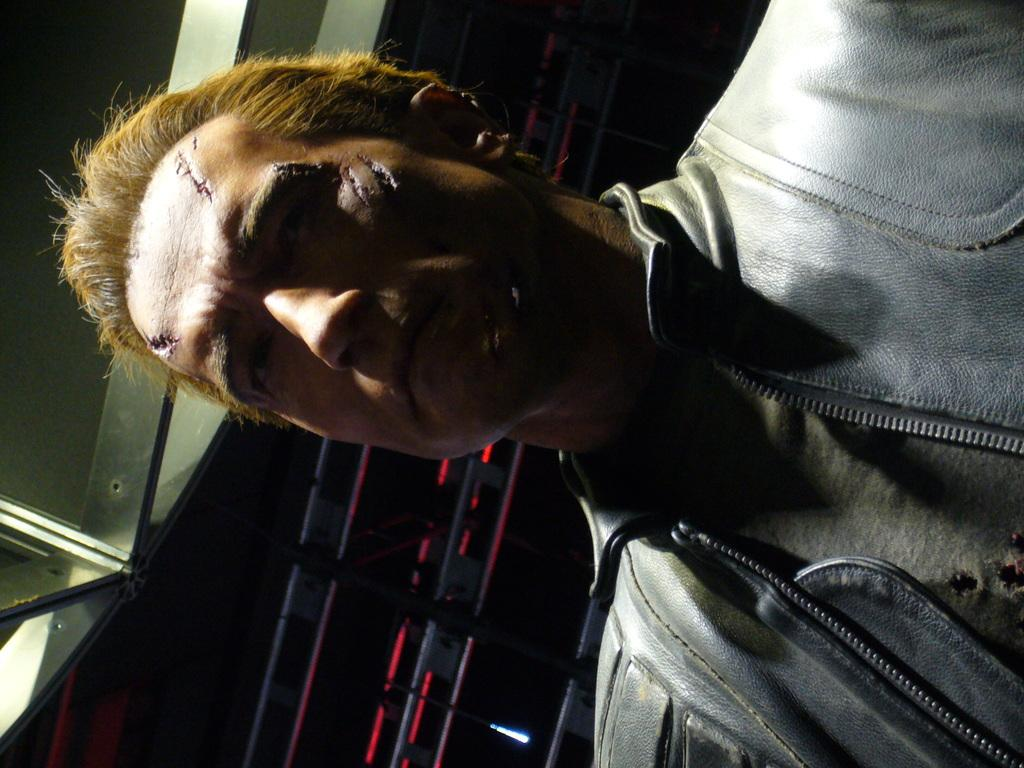Who is present in the image? There is a man in the image. What can be seen in the background of the image? There are lights in the background of the image. What object is visible in the image? There appears to be a pole in the image. What type of material is visible on the left side of the image? Iron rods are visible on the left side of the image. What type of stocking is the man wearing in the image? There is no information about the man's clothing, including stockings, in the image. How many servants are present in the image? There is no mention of servants in the image; only a man is present. 